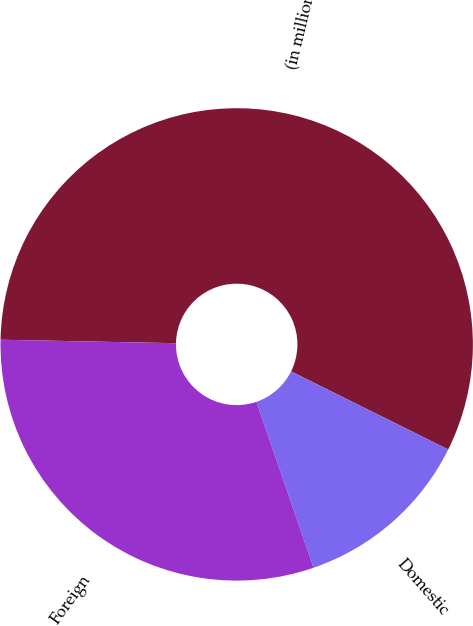Convert chart. <chart><loc_0><loc_0><loc_500><loc_500><pie_chart><fcel>(in millions)<fcel>Domestic<fcel>Foreign<nl><fcel>57.02%<fcel>12.39%<fcel>30.59%<nl></chart> 